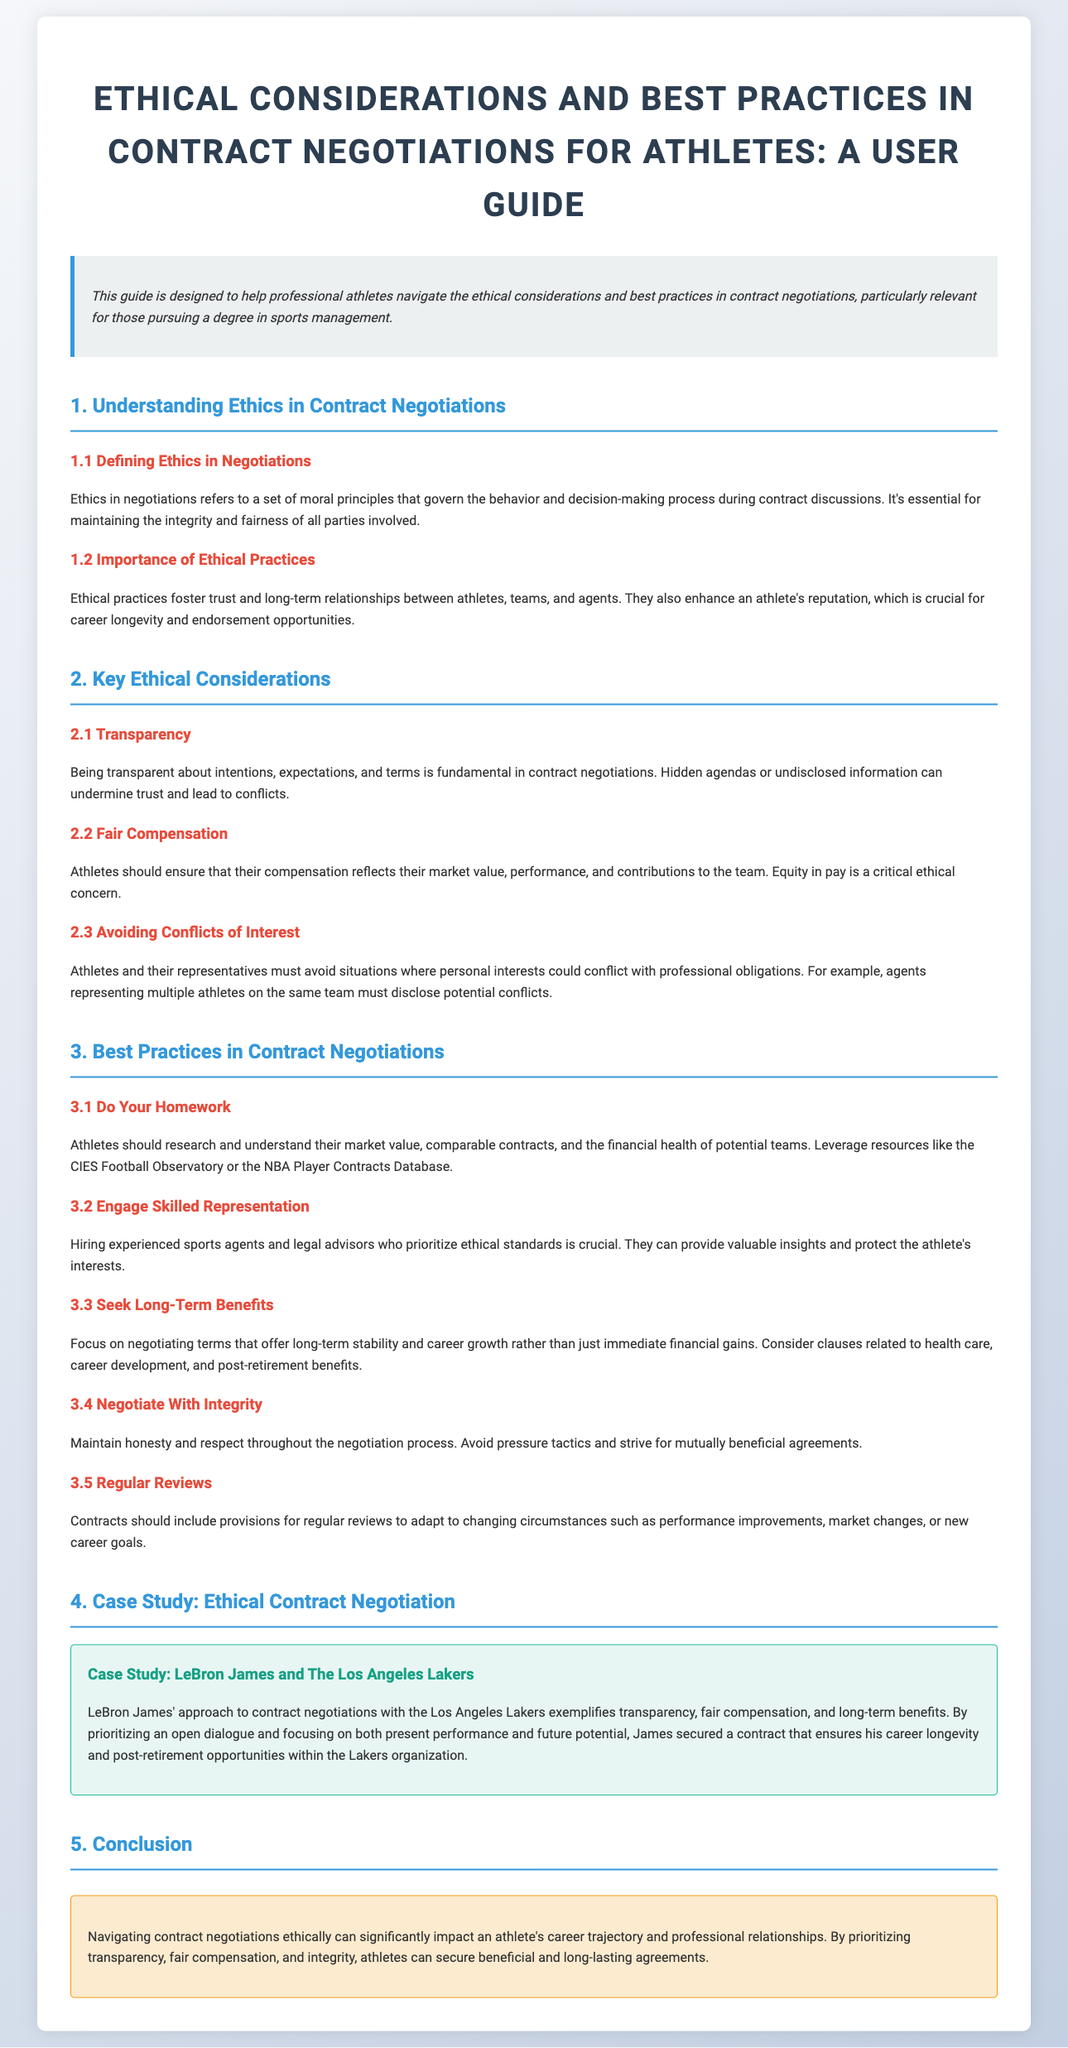What is the title of the user guide? The title is prominently displayed at the top of the document, summarizing its focus on ethical considerations and best practices.
Answer: Ethical Considerations and Best Practices in Contract Negotiations for Athletes: A User Guide What is the main objective of this guide? The introduction outlines that the guide aims to help professional athletes navigate ethical considerations and best practices in contract negotiations.
Answer: To help professional athletes navigate ethical considerations and best practices in contract negotiations What ethical principle emphasizes honesty and respect? The section on best practices specifies the importance of maintaining honesty and respect throughout the negotiation process.
Answer: Negotiate With Integrity What does the case study exemplify? The case study illustrates how LeBron James approached contract negotiations, focusing on key ethical considerations in practice.
Answer: Transparency, fair compensation, and long-term benefits What type of representation should athletes engage according to best practices? The document states that hiring experienced sports agents and legal advisors is crucial for protecting the athlete's interests.
Answer: Skilled representation How often should contracts include provisions for reviews? The section on best practices suggests including provisions for regular reviews in contracts.
Answer: Regular reviews What is essential for maintaining long-term relationships between athletes and teams? The importance of ethical practices is highlighted as a key factor in enhancing trust and long-term relationships.
Answer: Ethical practices What is considered a critical ethical concern regarding pay? The section discussing key ethical considerations includes a specific mention of the equity in pay as a critical issue.
Answer: Fair Compensation 